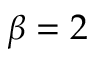<formula> <loc_0><loc_0><loc_500><loc_500>\beta = 2</formula> 